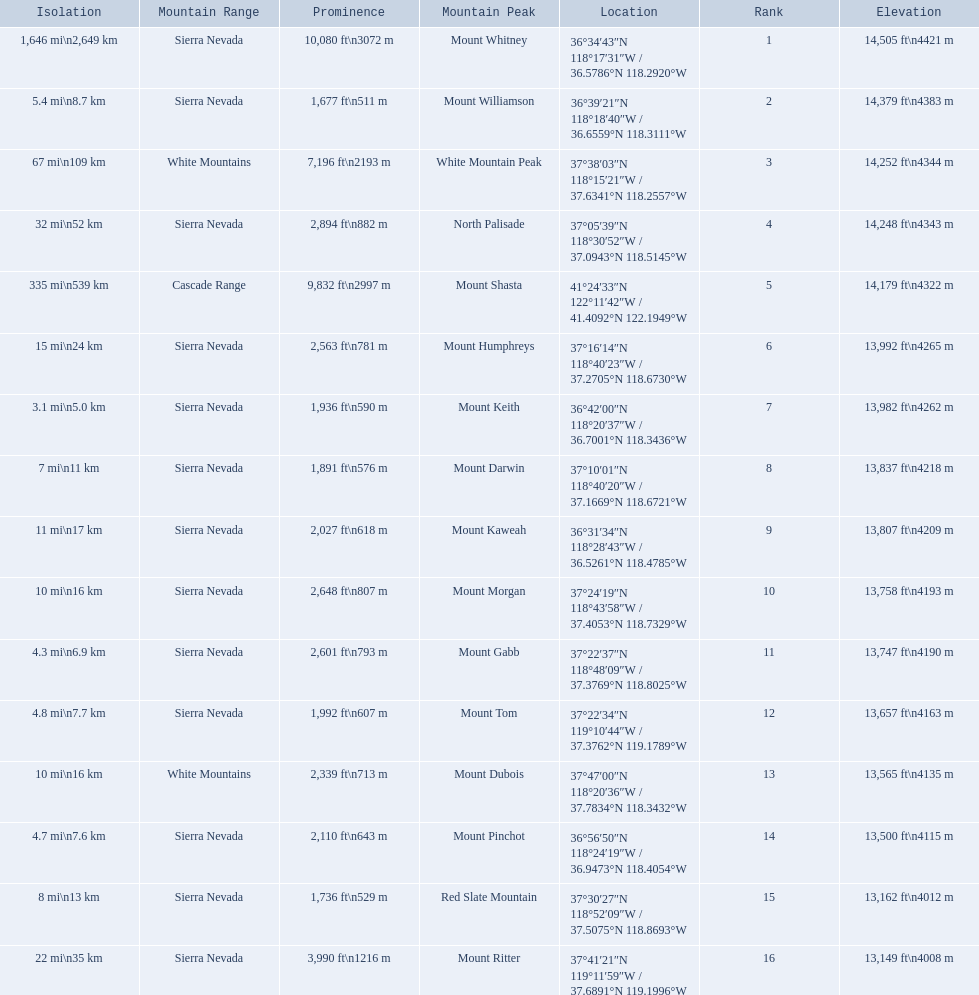What are all of the mountain peaks? Mount Whitney, Mount Williamson, White Mountain Peak, North Palisade, Mount Shasta, Mount Humphreys, Mount Keith, Mount Darwin, Mount Kaweah, Mount Morgan, Mount Gabb, Mount Tom, Mount Dubois, Mount Pinchot, Red Slate Mountain, Mount Ritter. In what ranges are they? Sierra Nevada, Sierra Nevada, White Mountains, Sierra Nevada, Cascade Range, Sierra Nevada, Sierra Nevada, Sierra Nevada, Sierra Nevada, Sierra Nevada, Sierra Nevada, Sierra Nevada, White Mountains, Sierra Nevada, Sierra Nevada, Sierra Nevada. Which peak is in the cascade range? Mount Shasta. 